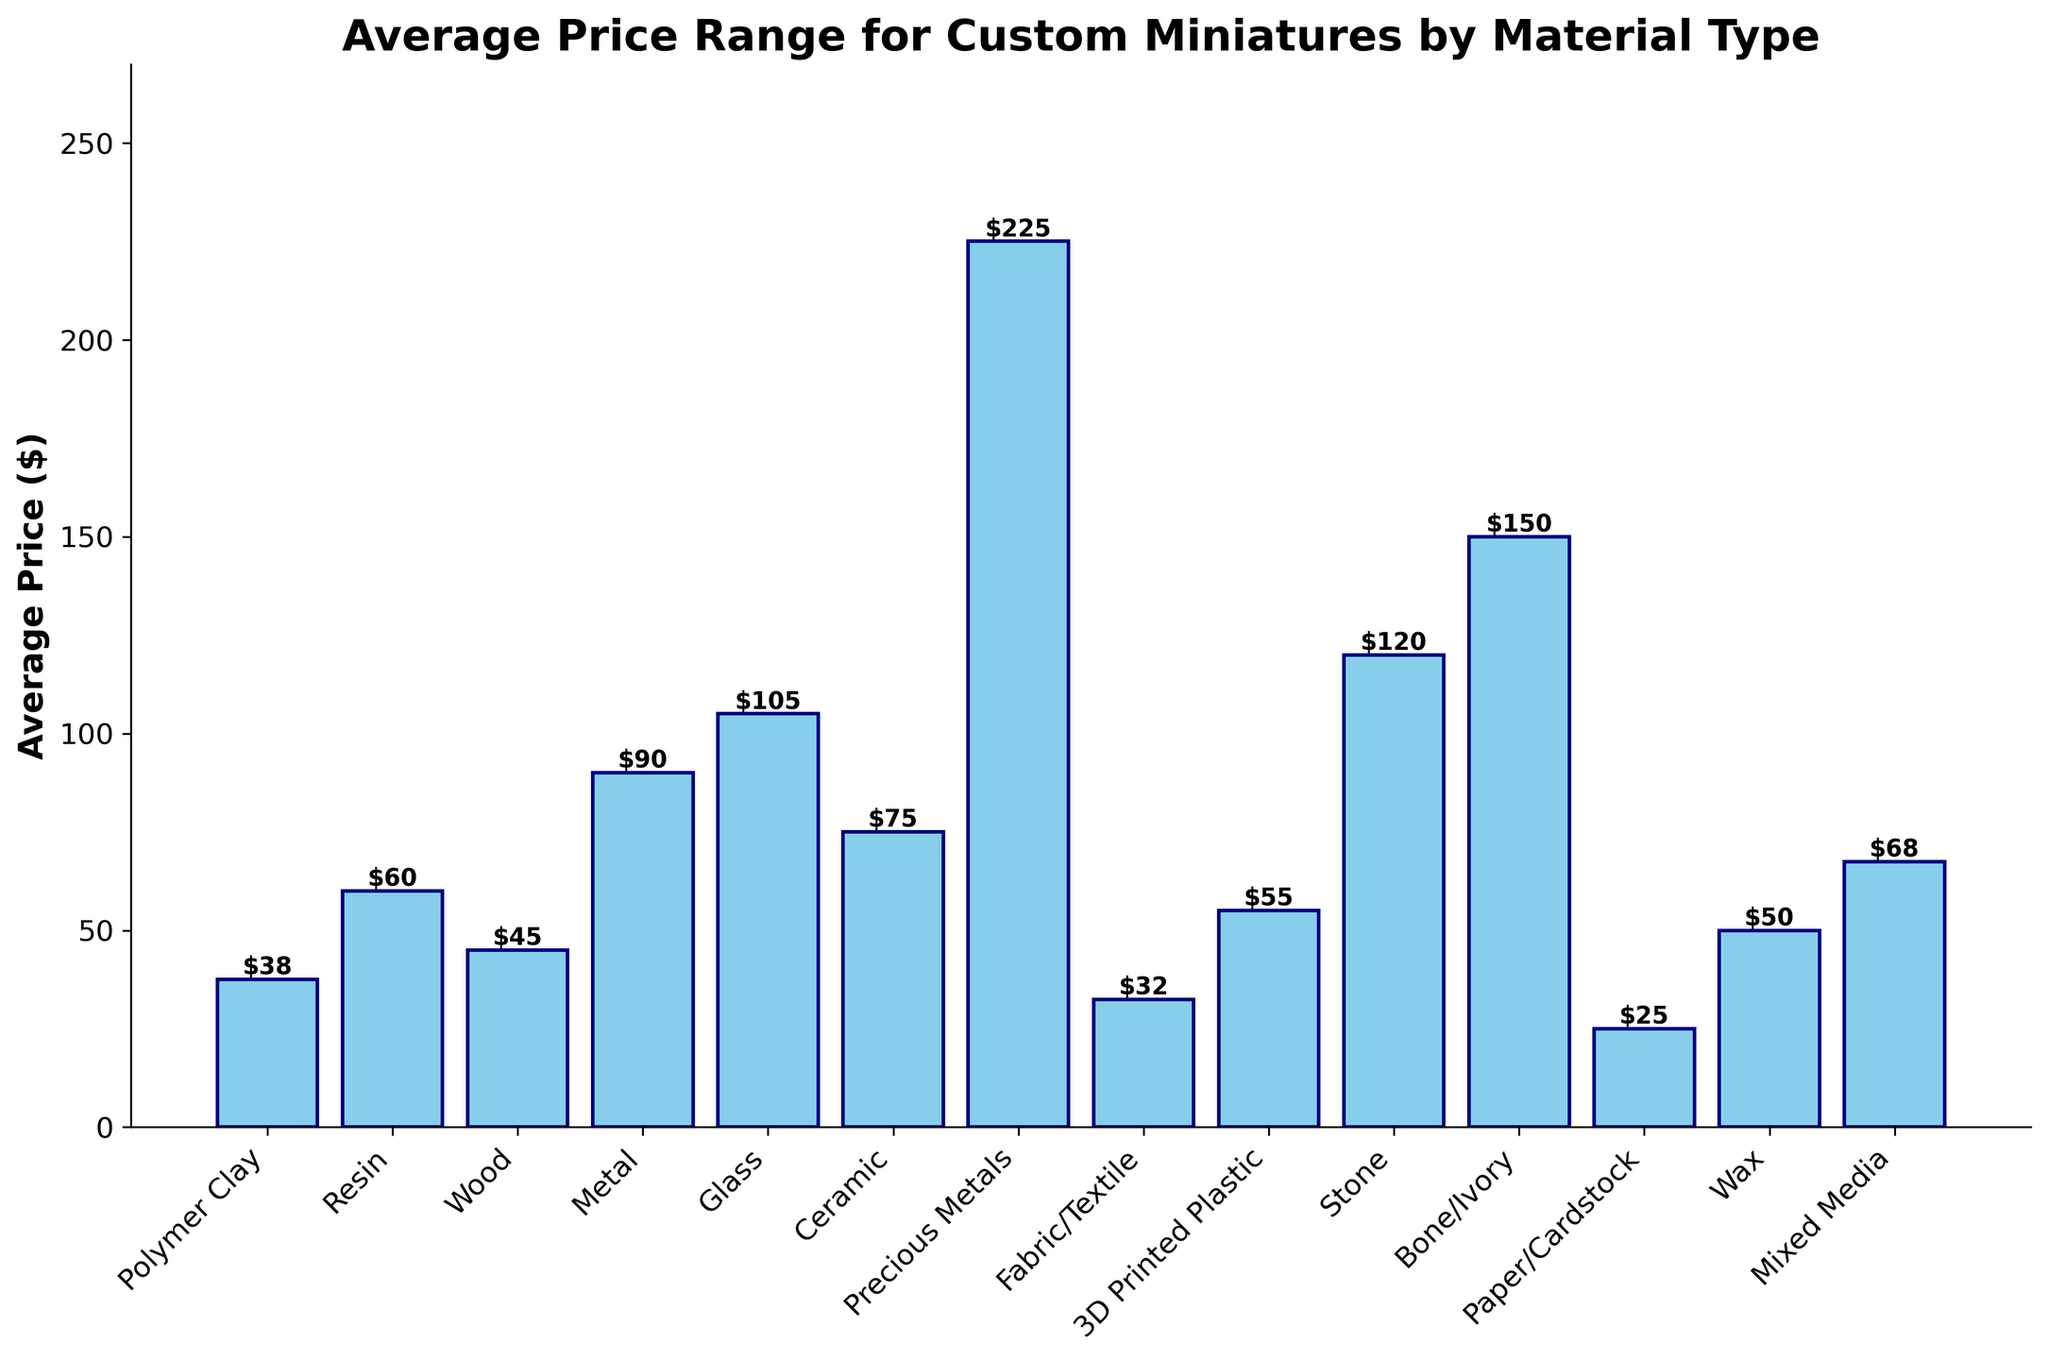What is the average price range for miniatures made from metal? The figure shows a bar representing the average price of custom miniatures by material type. For metal, the bar height represents the average price range.
Answer: 90 Which material has the highest average price for custom miniatures? From the figure, identify the tallest bar, which represents the highest average price. Precious Metals has the tallest bar.
Answer: Precious Metals Is the average price for custom miniatures made from wood higher or lower than those made from ceramic? Compare the heights of the bars labeled "Wood" and "Ceramic." The ceramic bar is taller than the wood bar, indicating ceramic has a higher average price.
Answer: Lower What is the difference in average price between miniatures made of bone/ivory and polymer clay? Look at the heights of the bars for Bone/Ivory and Polymer Clay. The bone/ivory bar is taller. Subtract the Polymer Clay average price from the Bone/Ivory average price. 150 (Bone/Ivory average) - 37.5 (Polymer Clay average) = 112.5
Answer: 112.5 What is the approximate combined average price range for custom miniatures made from fabric/textile and 3D printed plastic? Find the heights of the bars for Fabric/Textile and 3D Printed Plastic. Add the average prices: 32.5 (Fabric/Textile) + 55 (3D Printed Plastic) = 87.5
Answer: 87.5 Which material has the closest average price to $90? From the figure, find the bar with height closest to $90. Stone has an average price close to $90.
Answer: Stone What is the median value of the average price for the materials listed? Extract the average prices from all bars and list them: 32.5, 60, 45, 55, 105, 75, 47.5, 57.5, 120, 37.5, 32.5, 25, 52.5, 67.5. The median in this list is the middle value: 52.5.
Answer: 52.5 Which material type shows an average price range between $40 and $50? Check the bars whose average price falls within the $40-$50 range. Mixed Media has an average price of 67.5, while Polymer Clay has an average price of 37.5, slightly outside this range. Resin is what fits the $40-$50 range.
Answer: Resin 